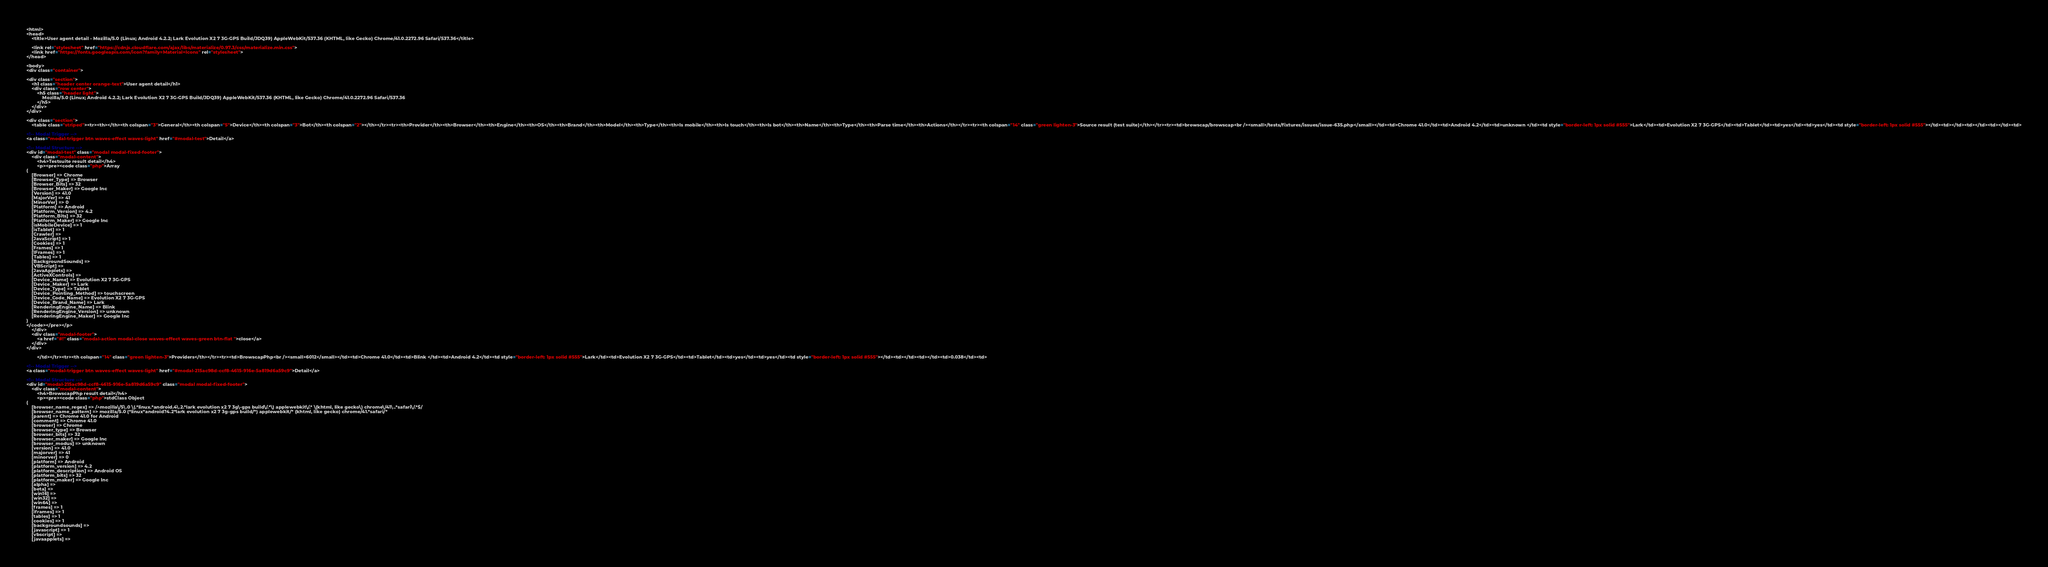Convert code to text. <code><loc_0><loc_0><loc_500><loc_500><_HTML_>
<html>
<head>
    <title>User agent detail - Mozilla/5.0 (Linux; Android 4.2.2; Lark Evolution X2 7 3G-GPS Build/JDQ39) AppleWebKit/537.36 (KHTML, like Gecko) Chrome/41.0.2272.96 Safari/537.36</title>
        
    <link rel="stylesheet" href="https://cdnjs.cloudflare.com/ajax/libs/materialize/0.97.3/css/materialize.min.css">
    <link href="https://fonts.googleapis.com/icon?family=Material+Icons" rel="stylesheet">
</head>
        
<body>
<div class="container">
    
<div class="section">
	<h1 class="header center orange-text">User agent detail</h1>
	<div class="row center">
        <h5 class="header light">
            Mozilla/5.0 (Linux; Android 4.2.2; Lark Evolution X2 7 3G-GPS Build/JDQ39) AppleWebKit/537.36 (KHTML, like Gecko) Chrome/41.0.2272.96 Safari/537.36
        </h5>
	</div>
</div>   

<div class="section">
    <table class="striped"><tr><th></th><th colspan="3">General</th><th colspan="5">Device</th><th colspan="3">Bot</th><th colspan="2"></th></tr><tr><th>Provider</th><th>Browser</th><th>Engine</th><th>OS</th><th>Brand</th><th>Model</th><th>Type</th><th>Is mobile</th><th>Is touch</th><th>Is bot</th><th>Name</th><th>Type</th><th>Parse time</th><th>Actions</th></tr><tr><th colspan="14" class="green lighten-3">Source result (test suite)</th></tr><tr><td>browscap/browscap<br /><small>/tests/fixtures/issues/issue-635.php</small></td><td>Chrome 41.0</td><td>Android 4.2</td><td>unknown </td><td style="border-left: 1px solid #555">Lark</td><td>Evolution X2 7 3G-GPS</td><td>Tablet</td><td>yes</td><td>yes</td><td style="border-left: 1px solid #555"></td><td></td><td></td><td></td><td>
                
<!-- Modal Trigger -->
<a class="modal-trigger btn waves-effect waves-light" href="#modal-test">Detail</a>

<!-- Modal Structure -->
<div id="modal-test" class="modal modal-fixed-footer">
    <div class="modal-content">
        <h4>Testsuite result detail</h4>
        <p><pre><code class="php">Array
(
    [Browser] => Chrome
    [Browser_Type] => Browser
    [Browser_Bits] => 32
    [Browser_Maker] => Google Inc
    [Version] => 41.0
    [MajorVer] => 41
    [MinorVer] => 0
    [Platform] => Android
    [Platform_Version] => 4.2
    [Platform_Bits] => 32
    [Platform_Maker] => Google Inc
    [isMobileDevice] => 1
    [isTablet] => 1
    [Crawler] => 
    [JavaScript] => 1
    [Cookies] => 1
    [Frames] => 1
    [IFrames] => 1
    [Tables] => 1
    [BackgroundSounds] => 
    [VBScript] => 
    [JavaApplets] => 
    [ActiveXControls] => 
    [Device_Name] => Evolution X2 7 3G-GPS
    [Device_Maker] => Lark
    [Device_Type] => Tablet
    [Device_Pointing_Method] => touchscreen
    [Device_Code_Name] => Evolution X2 7 3G-GPS
    [Device_Brand_Name] => Lark
    [RenderingEngine_Name] => Blink
    [RenderingEngine_Version] => unknown
    [RenderingEngine_Maker] => Google Inc
)
</code></pre></p>
    </div>
    <div class="modal-footer">
        <a href="#!" class="modal-action modal-close waves-effect waves-green btn-flat ">close</a>
    </div>
</div>
                
        </td></tr><tr><th colspan="14" class="green lighten-3">Providers</th></tr><tr><td>BrowscapPhp<br /><small>6012</small></td><td>Chrome 41.0</td><td>Blink </td><td>Android 4.2</td><td style="border-left: 1px solid #555">Lark</td><td>Evolution X2 7 3G-GPS</td><td>Tablet</td><td>yes</td><td>yes</td><td style="border-left: 1px solid #555"></td><td></td><td></td><td>0.038</td><td>
                
<!-- Modal Trigger -->
<a class="modal-trigger btn waves-effect waves-light" href="#modal-215ac98d-ccf8-4615-916e-5a819d6a59c9">Detail</a>

<!-- Modal Structure -->
<div id="modal-215ac98d-ccf8-4615-916e-5a819d6a59c9" class="modal modal-fixed-footer">
    <div class="modal-content">
        <h4>BrowscapPhp result detail</h4>
        <p><pre><code class="php">stdClass Object
(
    [browser_name_regex] => /^mozilla\/5\.0 \(.*linux.*android.4\.2.*lark evolution x2 7 3g\-gps build\/.*\) applewebkit\/.* \(khtml, like gecko\) chrome\/41\..*safari\/.*$/
    [browser_name_pattern] => mozilla/5.0 (*linux*android?4.2*lark evolution x2 7 3g-gps build/*) applewebkit/* (khtml, like gecko) chrome/41.*safari/*
    [parent] => Chrome 41.0 for Android
    [comment] => Chrome 41.0
    [browser] => Chrome
    [browser_type] => Browser
    [browser_bits] => 32
    [browser_maker] => Google Inc
    [browser_modus] => unknown
    [version] => 41.0
    [majorver] => 41
    [minorver] => 0
    [platform] => Android
    [platform_version] => 4.2
    [platform_description] => Android OS
    [platform_bits] => 32
    [platform_maker] => Google Inc
    [alpha] => 
    [beta] => 
    [win16] => 
    [win32] => 
    [win64] => 
    [frames] => 1
    [iframes] => 1
    [tables] => 1
    [cookies] => 1
    [backgroundsounds] => 
    [javascript] => 1
    [vbscript] => 
    [javaapplets] => </code> 